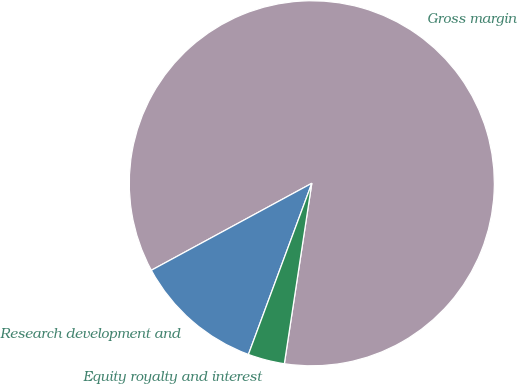Convert chart to OTSL. <chart><loc_0><loc_0><loc_500><loc_500><pie_chart><fcel>Gross margin<fcel>Research development and<fcel>Equity royalty and interest<nl><fcel>85.31%<fcel>11.45%<fcel>3.24%<nl></chart> 